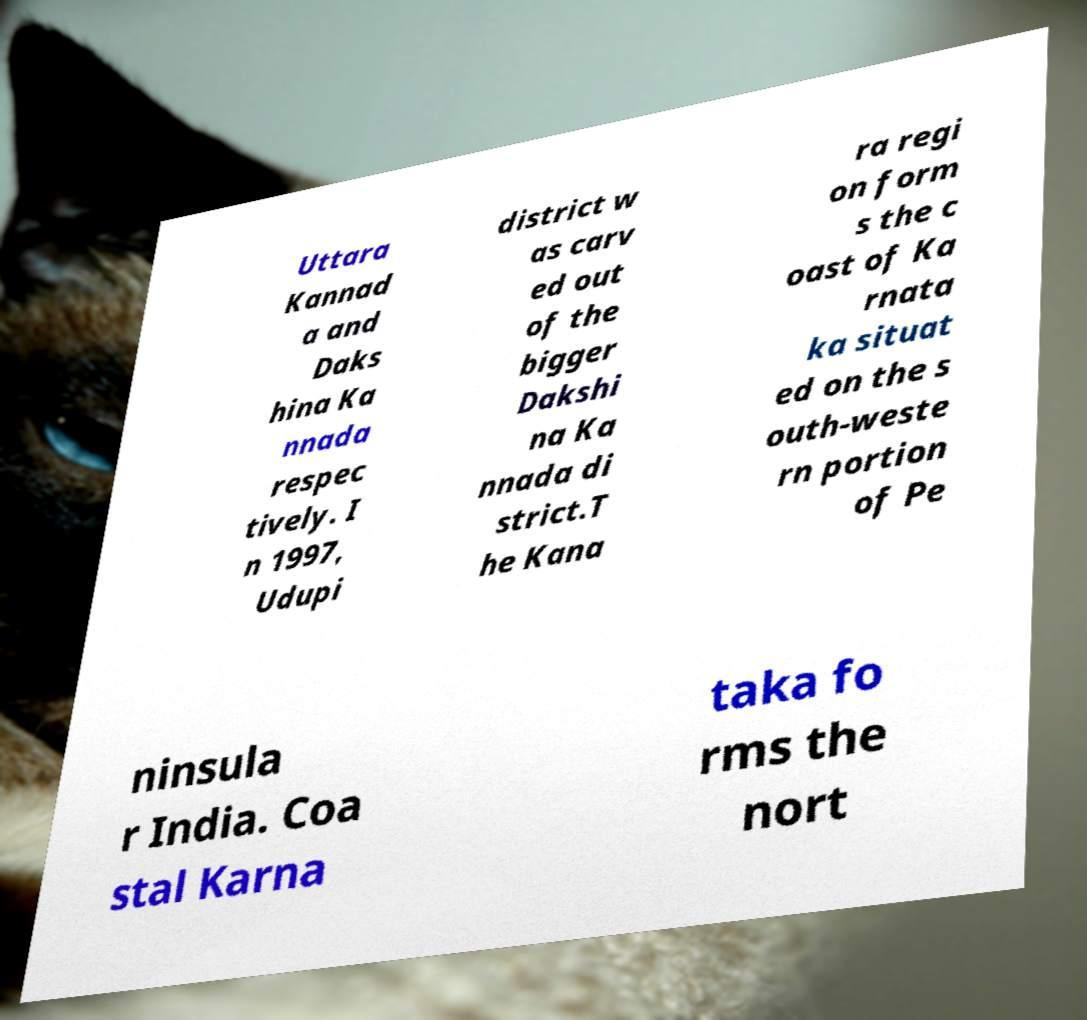Can you accurately transcribe the text from the provided image for me? Uttara Kannad a and Daks hina Ka nnada respec tively. I n 1997, Udupi district w as carv ed out of the bigger Dakshi na Ka nnada di strict.T he Kana ra regi on form s the c oast of Ka rnata ka situat ed on the s outh-weste rn portion of Pe ninsula r India. Coa stal Karna taka fo rms the nort 